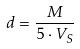Convert formula to latex. <formula><loc_0><loc_0><loc_500><loc_500>d = \frac { M } { 5 \cdot V _ { S } }</formula> 